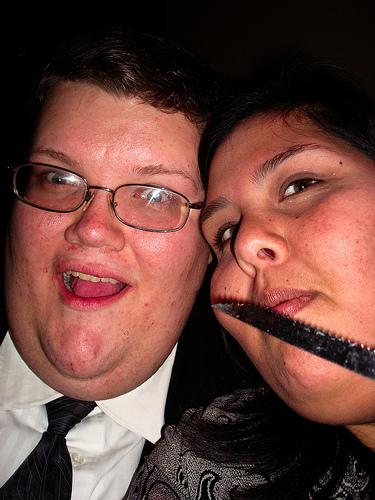Question: how are the people?
Choices:
A. Apart.
B. Happy.
C. Together.
D. Mad.
Answer with the letter. Answer: C Question: what color is the man coat?
Choices:
A. White.
B. Grey.
C. Black.
D. Blue.
Answer with the letter. Answer: C Question: where is the glasses?
Choices:
A. Face.
B. Top of head.
C. Hanging from a necklace.
D. In a purse.
Answer with the letter. Answer: A Question: who is laughing?
Choices:
A. Woman.
B. Man.
C. Child.
D. Dog.
Answer with the letter. Answer: B 